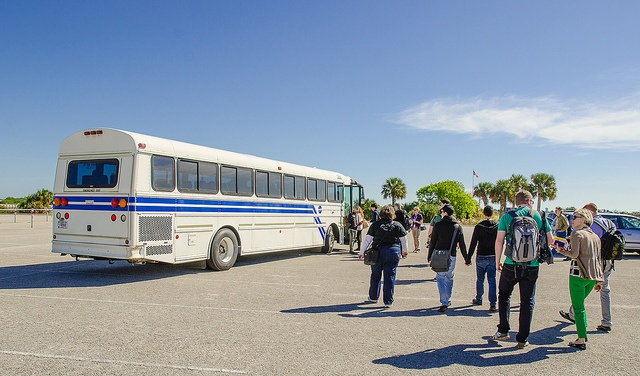Describe the objects in this image and their specific colors. I can see bus in blue, ivory, darkgray, gray, and black tones, people in blue, black, gray, darkgray, and teal tones, people in blue, darkgreen, gray, and black tones, people in blue, black, darkgray, gray, and navy tones, and people in blue, black, gray, and darkgray tones in this image. 